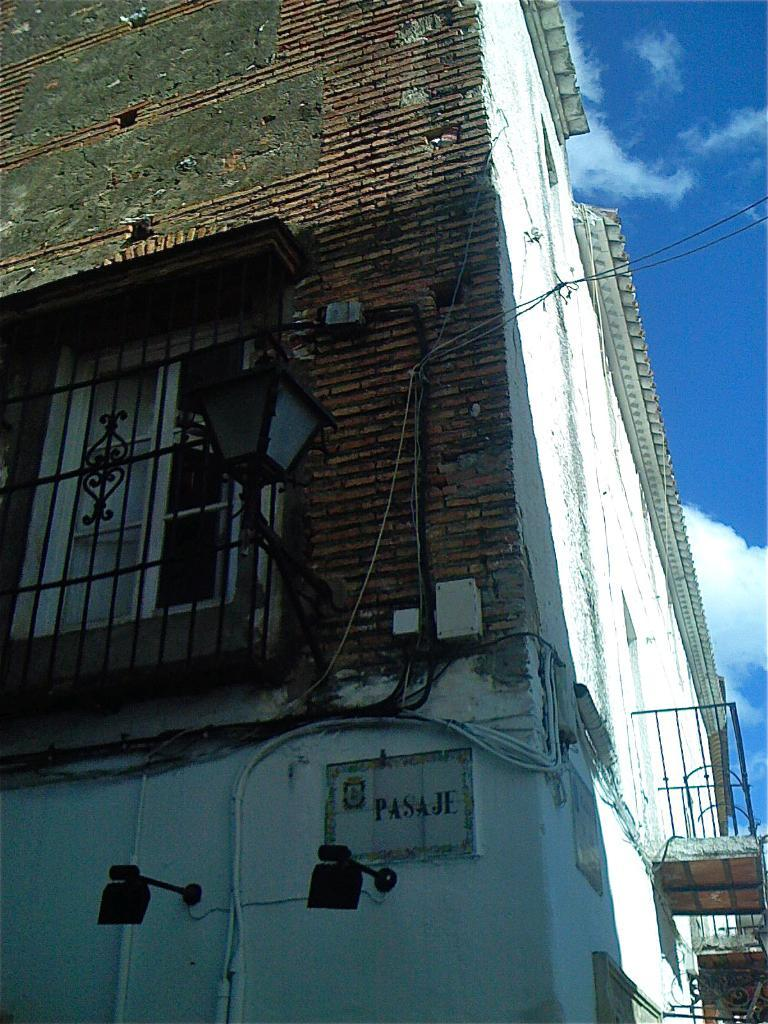What is attached to the wall in the image? There are wires and lights fixed to the wall in the image. Can you describe the window in the image? There is a window in the image. What structure is visible in the image? There is a building in the image. What can be seen in the background of the image? The sky with clouds is visible in the background of the image. Where is the vase placed in the image? There is no vase present in the image. What is the condition of the person's knee in the image? There are no people or knees visible in the image. 